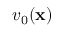Convert formula to latex. <formula><loc_0><loc_0><loc_500><loc_500>v _ { 0 } ( x )</formula> 